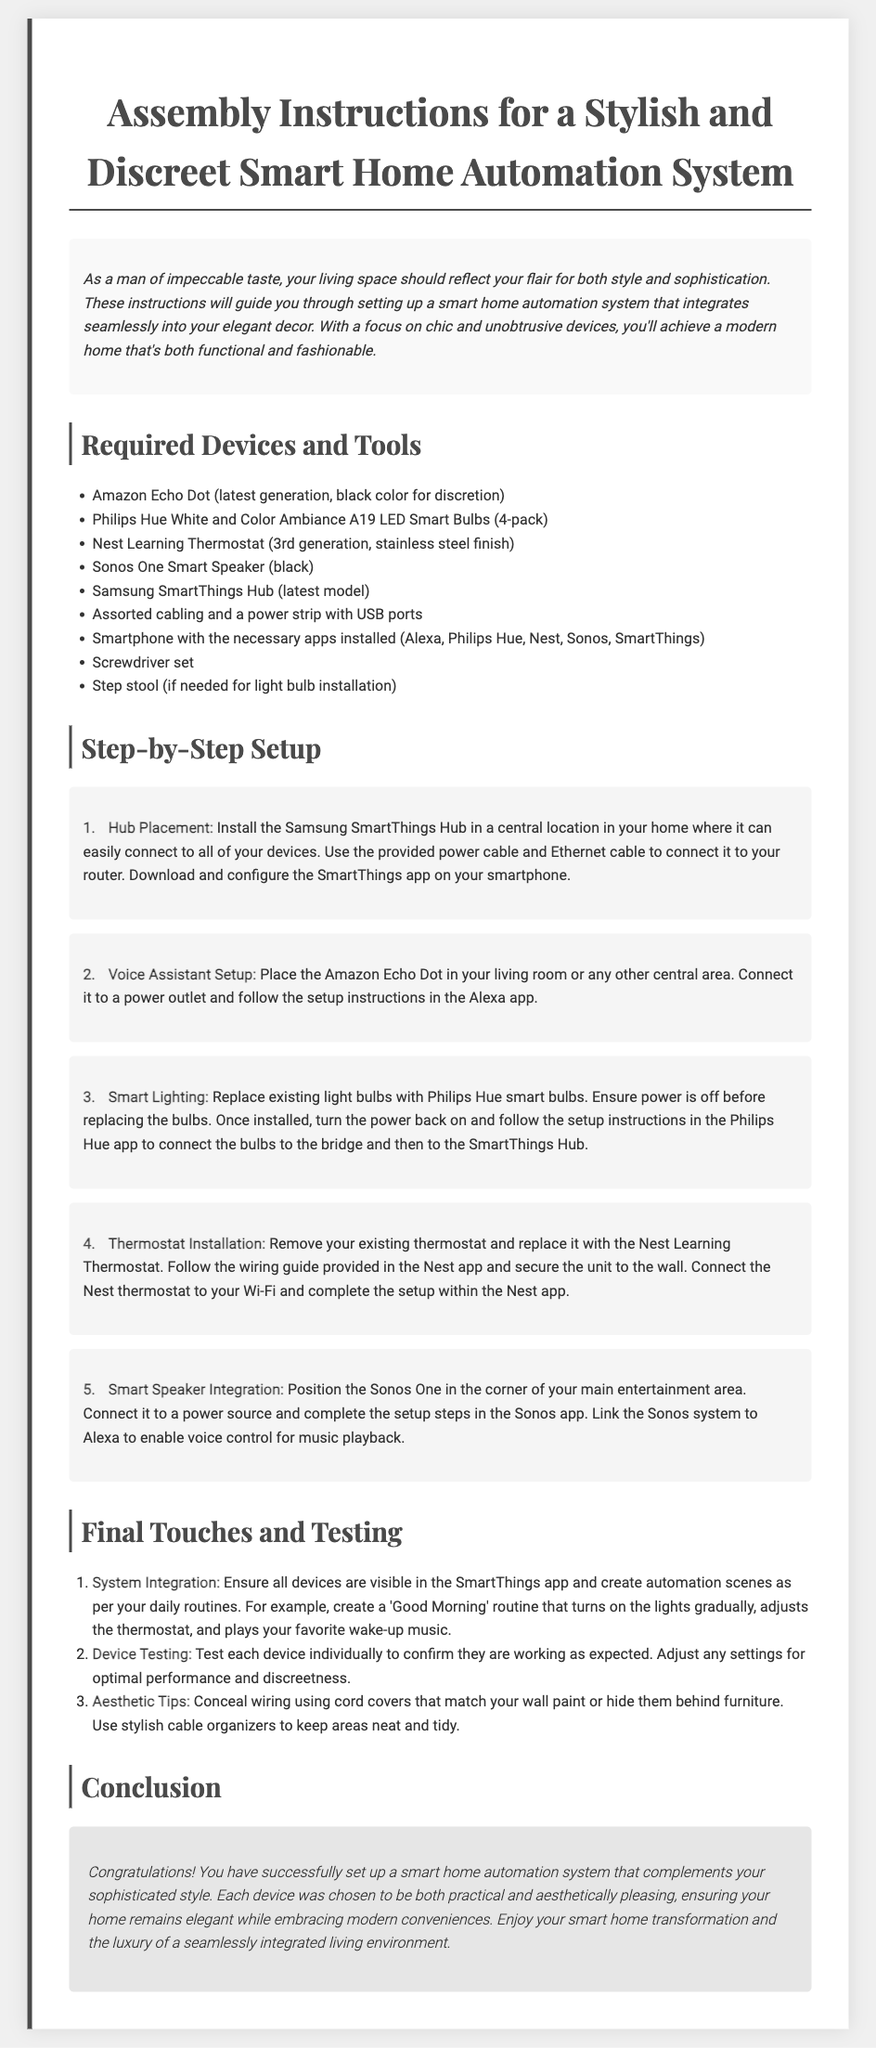What is the title of the document? The title of the document is listed in the <title> tag of the HTML, which is "Assembly Instructions for a Stylish and Discreet Smart Home Automation System."
Answer: Assembly Instructions for a Stylish and Discreet Smart Home Automation System How many smart bulbs are in the recommended pack? The document specifies a 4-pack of Philips Hue White and Color Ambiance A19 LED Smart Bulbs.
Answer: 4-pack Which device is installed in a central location? The first step discusses the placement of the Samsung SmartThings Hub, which should be installed centrally.
Answer: Samsung SmartThings Hub What color is the Amazon Echo Dot mentioned in the document? The Amazon Echo Dot is specifically noted to be in black color for discretion.
Answer: black Which app needs to be used for the thermostat installation? The Nest app is mentioned as the app needed to complete the thermostat installation.
Answer: Nest app How should wiring be concealed for aesthetic purposes? The document suggests using cord covers that match wall paint or hiding them behind furniture.
Answer: Cord covers List one device used for music playback in the system. The document mentions the Sonos One Smart Speaker for music playback.
Answer: Sonos One What routine is suggested for the morning automation scene? The document includes a 'Good Morning' routine as a suggestion for automation.
Answer: Good Morning What color is the Sonos One Smart Speaker? The Sonos One Smart Speaker is described as being black.
Answer: black 